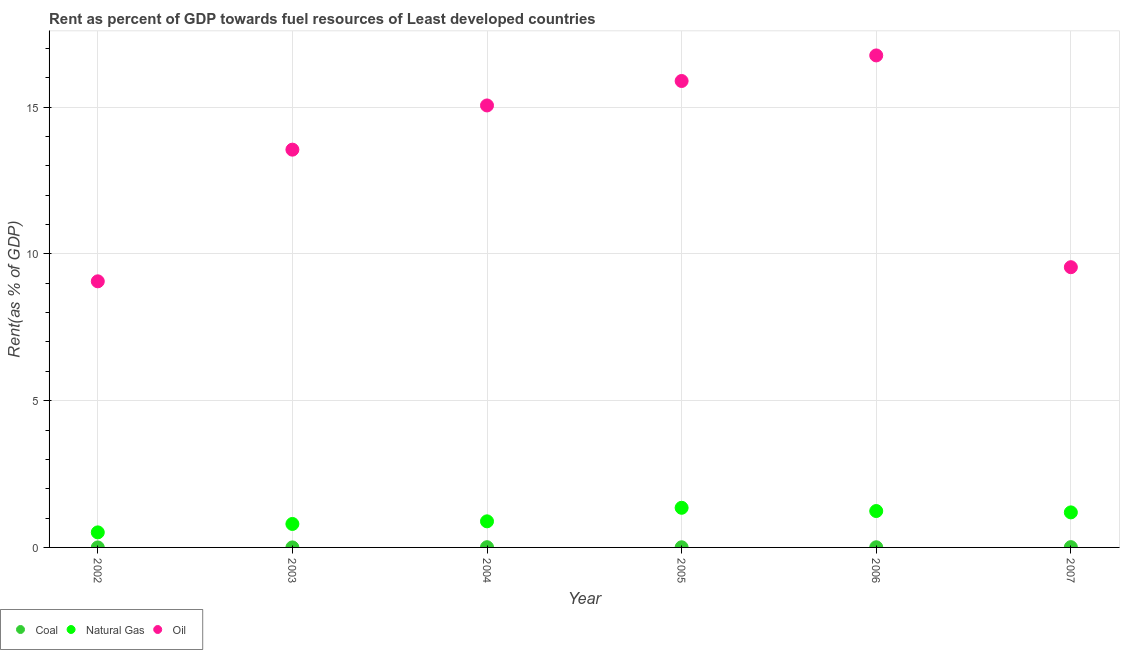How many different coloured dotlines are there?
Offer a very short reply. 3. What is the rent towards oil in 2007?
Make the answer very short. 9.55. Across all years, what is the maximum rent towards oil?
Your answer should be compact. 16.76. Across all years, what is the minimum rent towards natural gas?
Your answer should be very brief. 0.51. In which year was the rent towards coal minimum?
Your response must be concise. 2002. What is the total rent towards oil in the graph?
Your answer should be compact. 79.86. What is the difference between the rent towards natural gas in 2002 and that in 2005?
Provide a short and direct response. -0.84. What is the difference between the rent towards oil in 2003 and the rent towards natural gas in 2005?
Offer a terse response. 12.2. What is the average rent towards coal per year?
Your response must be concise. 0. In the year 2004, what is the difference between the rent towards oil and rent towards natural gas?
Ensure brevity in your answer.  14.17. In how many years, is the rent towards oil greater than 4 %?
Ensure brevity in your answer.  6. What is the ratio of the rent towards coal in 2002 to that in 2006?
Your answer should be very brief. 0.04. Is the rent towards natural gas in 2003 less than that in 2006?
Provide a succinct answer. Yes. Is the difference between the rent towards natural gas in 2004 and 2006 greater than the difference between the rent towards oil in 2004 and 2006?
Offer a very short reply. Yes. What is the difference between the highest and the second highest rent towards natural gas?
Your answer should be very brief. 0.11. What is the difference between the highest and the lowest rent towards oil?
Ensure brevity in your answer.  7.7. Is the sum of the rent towards coal in 2005 and 2006 greater than the maximum rent towards natural gas across all years?
Give a very brief answer. No. Is the rent towards oil strictly greater than the rent towards coal over the years?
Give a very brief answer. Yes. Is the rent towards oil strictly less than the rent towards natural gas over the years?
Provide a succinct answer. No. How many dotlines are there?
Offer a terse response. 3. How many years are there in the graph?
Your response must be concise. 6. What is the difference between two consecutive major ticks on the Y-axis?
Provide a succinct answer. 5. How are the legend labels stacked?
Offer a very short reply. Horizontal. What is the title of the graph?
Provide a succinct answer. Rent as percent of GDP towards fuel resources of Least developed countries. Does "Tertiary" appear as one of the legend labels in the graph?
Your answer should be compact. No. What is the label or title of the X-axis?
Your answer should be very brief. Year. What is the label or title of the Y-axis?
Your answer should be compact. Rent(as % of GDP). What is the Rent(as % of GDP) of Coal in 2002?
Give a very brief answer. 0. What is the Rent(as % of GDP) of Natural Gas in 2002?
Your answer should be very brief. 0.51. What is the Rent(as % of GDP) in Oil in 2002?
Your response must be concise. 9.06. What is the Rent(as % of GDP) of Coal in 2003?
Ensure brevity in your answer.  0. What is the Rent(as % of GDP) in Natural Gas in 2003?
Offer a terse response. 0.8. What is the Rent(as % of GDP) in Oil in 2003?
Keep it short and to the point. 13.55. What is the Rent(as % of GDP) in Coal in 2004?
Offer a terse response. 0.01. What is the Rent(as % of GDP) of Natural Gas in 2004?
Give a very brief answer. 0.89. What is the Rent(as % of GDP) in Oil in 2004?
Offer a very short reply. 15.06. What is the Rent(as % of GDP) in Coal in 2005?
Offer a terse response. 0. What is the Rent(as % of GDP) of Natural Gas in 2005?
Your answer should be compact. 1.35. What is the Rent(as % of GDP) of Oil in 2005?
Provide a short and direct response. 15.89. What is the Rent(as % of GDP) in Coal in 2006?
Offer a very short reply. 0.01. What is the Rent(as % of GDP) in Natural Gas in 2006?
Offer a very short reply. 1.24. What is the Rent(as % of GDP) in Oil in 2006?
Provide a short and direct response. 16.76. What is the Rent(as % of GDP) in Coal in 2007?
Ensure brevity in your answer.  0.01. What is the Rent(as % of GDP) in Natural Gas in 2007?
Ensure brevity in your answer.  1.19. What is the Rent(as % of GDP) of Oil in 2007?
Keep it short and to the point. 9.55. Across all years, what is the maximum Rent(as % of GDP) in Coal?
Ensure brevity in your answer.  0.01. Across all years, what is the maximum Rent(as % of GDP) in Natural Gas?
Give a very brief answer. 1.35. Across all years, what is the maximum Rent(as % of GDP) in Oil?
Your response must be concise. 16.76. Across all years, what is the minimum Rent(as % of GDP) in Coal?
Give a very brief answer. 0. Across all years, what is the minimum Rent(as % of GDP) of Natural Gas?
Your response must be concise. 0.51. Across all years, what is the minimum Rent(as % of GDP) in Oil?
Ensure brevity in your answer.  9.06. What is the total Rent(as % of GDP) in Coal in the graph?
Keep it short and to the point. 0.03. What is the total Rent(as % of GDP) in Natural Gas in the graph?
Ensure brevity in your answer.  5.98. What is the total Rent(as % of GDP) in Oil in the graph?
Give a very brief answer. 79.86. What is the difference between the Rent(as % of GDP) in Coal in 2002 and that in 2003?
Provide a short and direct response. -0. What is the difference between the Rent(as % of GDP) of Natural Gas in 2002 and that in 2003?
Give a very brief answer. -0.29. What is the difference between the Rent(as % of GDP) of Oil in 2002 and that in 2003?
Offer a terse response. -4.49. What is the difference between the Rent(as % of GDP) of Coal in 2002 and that in 2004?
Offer a terse response. -0.01. What is the difference between the Rent(as % of GDP) in Natural Gas in 2002 and that in 2004?
Ensure brevity in your answer.  -0.38. What is the difference between the Rent(as % of GDP) in Oil in 2002 and that in 2004?
Your response must be concise. -5.99. What is the difference between the Rent(as % of GDP) of Coal in 2002 and that in 2005?
Your answer should be very brief. -0. What is the difference between the Rent(as % of GDP) in Natural Gas in 2002 and that in 2005?
Offer a terse response. -0.84. What is the difference between the Rent(as % of GDP) in Oil in 2002 and that in 2005?
Make the answer very short. -6.82. What is the difference between the Rent(as % of GDP) in Coal in 2002 and that in 2006?
Give a very brief answer. -0.01. What is the difference between the Rent(as % of GDP) of Natural Gas in 2002 and that in 2006?
Offer a very short reply. -0.73. What is the difference between the Rent(as % of GDP) in Oil in 2002 and that in 2006?
Provide a succinct answer. -7.7. What is the difference between the Rent(as % of GDP) in Coal in 2002 and that in 2007?
Give a very brief answer. -0.01. What is the difference between the Rent(as % of GDP) in Natural Gas in 2002 and that in 2007?
Give a very brief answer. -0.68. What is the difference between the Rent(as % of GDP) in Oil in 2002 and that in 2007?
Offer a terse response. -0.48. What is the difference between the Rent(as % of GDP) of Coal in 2003 and that in 2004?
Provide a short and direct response. -0.01. What is the difference between the Rent(as % of GDP) of Natural Gas in 2003 and that in 2004?
Provide a short and direct response. -0.09. What is the difference between the Rent(as % of GDP) in Oil in 2003 and that in 2004?
Provide a succinct answer. -1.51. What is the difference between the Rent(as % of GDP) in Coal in 2003 and that in 2005?
Ensure brevity in your answer.  -0. What is the difference between the Rent(as % of GDP) in Natural Gas in 2003 and that in 2005?
Ensure brevity in your answer.  -0.55. What is the difference between the Rent(as % of GDP) of Oil in 2003 and that in 2005?
Ensure brevity in your answer.  -2.34. What is the difference between the Rent(as % of GDP) in Coal in 2003 and that in 2006?
Keep it short and to the point. -0.01. What is the difference between the Rent(as % of GDP) in Natural Gas in 2003 and that in 2006?
Your answer should be compact. -0.44. What is the difference between the Rent(as % of GDP) in Oil in 2003 and that in 2006?
Offer a very short reply. -3.21. What is the difference between the Rent(as % of GDP) in Coal in 2003 and that in 2007?
Make the answer very short. -0.01. What is the difference between the Rent(as % of GDP) in Natural Gas in 2003 and that in 2007?
Provide a succinct answer. -0.39. What is the difference between the Rent(as % of GDP) of Oil in 2003 and that in 2007?
Offer a very short reply. 4. What is the difference between the Rent(as % of GDP) of Coal in 2004 and that in 2005?
Keep it short and to the point. 0. What is the difference between the Rent(as % of GDP) in Natural Gas in 2004 and that in 2005?
Provide a short and direct response. -0.46. What is the difference between the Rent(as % of GDP) in Oil in 2004 and that in 2005?
Offer a terse response. -0.83. What is the difference between the Rent(as % of GDP) in Coal in 2004 and that in 2006?
Give a very brief answer. 0. What is the difference between the Rent(as % of GDP) of Natural Gas in 2004 and that in 2006?
Ensure brevity in your answer.  -0.35. What is the difference between the Rent(as % of GDP) of Oil in 2004 and that in 2006?
Provide a succinct answer. -1.7. What is the difference between the Rent(as % of GDP) of Coal in 2004 and that in 2007?
Provide a succinct answer. -0. What is the difference between the Rent(as % of GDP) in Natural Gas in 2004 and that in 2007?
Offer a very short reply. -0.3. What is the difference between the Rent(as % of GDP) of Oil in 2004 and that in 2007?
Give a very brief answer. 5.51. What is the difference between the Rent(as % of GDP) in Coal in 2005 and that in 2006?
Your response must be concise. -0. What is the difference between the Rent(as % of GDP) in Natural Gas in 2005 and that in 2006?
Give a very brief answer. 0.11. What is the difference between the Rent(as % of GDP) in Oil in 2005 and that in 2006?
Ensure brevity in your answer.  -0.87. What is the difference between the Rent(as % of GDP) of Coal in 2005 and that in 2007?
Make the answer very short. -0.01. What is the difference between the Rent(as % of GDP) in Natural Gas in 2005 and that in 2007?
Offer a terse response. 0.16. What is the difference between the Rent(as % of GDP) of Oil in 2005 and that in 2007?
Your answer should be compact. 6.34. What is the difference between the Rent(as % of GDP) of Coal in 2006 and that in 2007?
Offer a terse response. -0. What is the difference between the Rent(as % of GDP) of Natural Gas in 2006 and that in 2007?
Make the answer very short. 0.05. What is the difference between the Rent(as % of GDP) in Oil in 2006 and that in 2007?
Provide a short and direct response. 7.21. What is the difference between the Rent(as % of GDP) of Coal in 2002 and the Rent(as % of GDP) of Natural Gas in 2003?
Ensure brevity in your answer.  -0.8. What is the difference between the Rent(as % of GDP) of Coal in 2002 and the Rent(as % of GDP) of Oil in 2003?
Make the answer very short. -13.55. What is the difference between the Rent(as % of GDP) of Natural Gas in 2002 and the Rent(as % of GDP) of Oil in 2003?
Your response must be concise. -13.04. What is the difference between the Rent(as % of GDP) of Coal in 2002 and the Rent(as % of GDP) of Natural Gas in 2004?
Your answer should be very brief. -0.89. What is the difference between the Rent(as % of GDP) in Coal in 2002 and the Rent(as % of GDP) in Oil in 2004?
Offer a very short reply. -15.06. What is the difference between the Rent(as % of GDP) in Natural Gas in 2002 and the Rent(as % of GDP) in Oil in 2004?
Provide a succinct answer. -14.54. What is the difference between the Rent(as % of GDP) of Coal in 2002 and the Rent(as % of GDP) of Natural Gas in 2005?
Make the answer very short. -1.35. What is the difference between the Rent(as % of GDP) in Coal in 2002 and the Rent(as % of GDP) in Oil in 2005?
Keep it short and to the point. -15.89. What is the difference between the Rent(as % of GDP) of Natural Gas in 2002 and the Rent(as % of GDP) of Oil in 2005?
Ensure brevity in your answer.  -15.38. What is the difference between the Rent(as % of GDP) of Coal in 2002 and the Rent(as % of GDP) of Natural Gas in 2006?
Make the answer very short. -1.24. What is the difference between the Rent(as % of GDP) of Coal in 2002 and the Rent(as % of GDP) of Oil in 2006?
Provide a short and direct response. -16.76. What is the difference between the Rent(as % of GDP) of Natural Gas in 2002 and the Rent(as % of GDP) of Oil in 2006?
Provide a short and direct response. -16.25. What is the difference between the Rent(as % of GDP) in Coal in 2002 and the Rent(as % of GDP) in Natural Gas in 2007?
Provide a succinct answer. -1.19. What is the difference between the Rent(as % of GDP) in Coal in 2002 and the Rent(as % of GDP) in Oil in 2007?
Give a very brief answer. -9.55. What is the difference between the Rent(as % of GDP) of Natural Gas in 2002 and the Rent(as % of GDP) of Oil in 2007?
Ensure brevity in your answer.  -9.03. What is the difference between the Rent(as % of GDP) of Coal in 2003 and the Rent(as % of GDP) of Natural Gas in 2004?
Provide a short and direct response. -0.89. What is the difference between the Rent(as % of GDP) in Coal in 2003 and the Rent(as % of GDP) in Oil in 2004?
Make the answer very short. -15.06. What is the difference between the Rent(as % of GDP) of Natural Gas in 2003 and the Rent(as % of GDP) of Oil in 2004?
Offer a very short reply. -14.26. What is the difference between the Rent(as % of GDP) of Coal in 2003 and the Rent(as % of GDP) of Natural Gas in 2005?
Give a very brief answer. -1.35. What is the difference between the Rent(as % of GDP) in Coal in 2003 and the Rent(as % of GDP) in Oil in 2005?
Ensure brevity in your answer.  -15.89. What is the difference between the Rent(as % of GDP) in Natural Gas in 2003 and the Rent(as % of GDP) in Oil in 2005?
Offer a very short reply. -15.09. What is the difference between the Rent(as % of GDP) in Coal in 2003 and the Rent(as % of GDP) in Natural Gas in 2006?
Make the answer very short. -1.24. What is the difference between the Rent(as % of GDP) of Coal in 2003 and the Rent(as % of GDP) of Oil in 2006?
Provide a succinct answer. -16.76. What is the difference between the Rent(as % of GDP) in Natural Gas in 2003 and the Rent(as % of GDP) in Oil in 2006?
Offer a terse response. -15.96. What is the difference between the Rent(as % of GDP) of Coal in 2003 and the Rent(as % of GDP) of Natural Gas in 2007?
Offer a very short reply. -1.19. What is the difference between the Rent(as % of GDP) in Coal in 2003 and the Rent(as % of GDP) in Oil in 2007?
Offer a terse response. -9.55. What is the difference between the Rent(as % of GDP) in Natural Gas in 2003 and the Rent(as % of GDP) in Oil in 2007?
Make the answer very short. -8.75. What is the difference between the Rent(as % of GDP) in Coal in 2004 and the Rent(as % of GDP) in Natural Gas in 2005?
Provide a succinct answer. -1.34. What is the difference between the Rent(as % of GDP) of Coal in 2004 and the Rent(as % of GDP) of Oil in 2005?
Give a very brief answer. -15.88. What is the difference between the Rent(as % of GDP) of Natural Gas in 2004 and the Rent(as % of GDP) of Oil in 2005?
Offer a very short reply. -15. What is the difference between the Rent(as % of GDP) of Coal in 2004 and the Rent(as % of GDP) of Natural Gas in 2006?
Your answer should be very brief. -1.23. What is the difference between the Rent(as % of GDP) in Coal in 2004 and the Rent(as % of GDP) in Oil in 2006?
Offer a terse response. -16.75. What is the difference between the Rent(as % of GDP) of Natural Gas in 2004 and the Rent(as % of GDP) of Oil in 2006?
Give a very brief answer. -15.87. What is the difference between the Rent(as % of GDP) in Coal in 2004 and the Rent(as % of GDP) in Natural Gas in 2007?
Keep it short and to the point. -1.19. What is the difference between the Rent(as % of GDP) in Coal in 2004 and the Rent(as % of GDP) in Oil in 2007?
Offer a terse response. -9.54. What is the difference between the Rent(as % of GDP) in Natural Gas in 2004 and the Rent(as % of GDP) in Oil in 2007?
Keep it short and to the point. -8.66. What is the difference between the Rent(as % of GDP) of Coal in 2005 and the Rent(as % of GDP) of Natural Gas in 2006?
Make the answer very short. -1.23. What is the difference between the Rent(as % of GDP) in Coal in 2005 and the Rent(as % of GDP) in Oil in 2006?
Offer a very short reply. -16.75. What is the difference between the Rent(as % of GDP) in Natural Gas in 2005 and the Rent(as % of GDP) in Oil in 2006?
Give a very brief answer. -15.41. What is the difference between the Rent(as % of GDP) of Coal in 2005 and the Rent(as % of GDP) of Natural Gas in 2007?
Provide a short and direct response. -1.19. What is the difference between the Rent(as % of GDP) of Coal in 2005 and the Rent(as % of GDP) of Oil in 2007?
Keep it short and to the point. -9.54. What is the difference between the Rent(as % of GDP) in Natural Gas in 2005 and the Rent(as % of GDP) in Oil in 2007?
Offer a very short reply. -8.2. What is the difference between the Rent(as % of GDP) of Coal in 2006 and the Rent(as % of GDP) of Natural Gas in 2007?
Your answer should be very brief. -1.19. What is the difference between the Rent(as % of GDP) in Coal in 2006 and the Rent(as % of GDP) in Oil in 2007?
Make the answer very short. -9.54. What is the difference between the Rent(as % of GDP) of Natural Gas in 2006 and the Rent(as % of GDP) of Oil in 2007?
Give a very brief answer. -8.31. What is the average Rent(as % of GDP) of Coal per year?
Provide a short and direct response. 0. What is the average Rent(as % of GDP) of Oil per year?
Offer a terse response. 13.31. In the year 2002, what is the difference between the Rent(as % of GDP) in Coal and Rent(as % of GDP) in Natural Gas?
Offer a terse response. -0.51. In the year 2002, what is the difference between the Rent(as % of GDP) in Coal and Rent(as % of GDP) in Oil?
Provide a succinct answer. -9.06. In the year 2002, what is the difference between the Rent(as % of GDP) of Natural Gas and Rent(as % of GDP) of Oil?
Make the answer very short. -8.55. In the year 2003, what is the difference between the Rent(as % of GDP) in Coal and Rent(as % of GDP) in Natural Gas?
Ensure brevity in your answer.  -0.8. In the year 2003, what is the difference between the Rent(as % of GDP) in Coal and Rent(as % of GDP) in Oil?
Give a very brief answer. -13.55. In the year 2003, what is the difference between the Rent(as % of GDP) of Natural Gas and Rent(as % of GDP) of Oil?
Offer a very short reply. -12.75. In the year 2004, what is the difference between the Rent(as % of GDP) of Coal and Rent(as % of GDP) of Natural Gas?
Give a very brief answer. -0.88. In the year 2004, what is the difference between the Rent(as % of GDP) of Coal and Rent(as % of GDP) of Oil?
Provide a succinct answer. -15.05. In the year 2004, what is the difference between the Rent(as % of GDP) of Natural Gas and Rent(as % of GDP) of Oil?
Provide a succinct answer. -14.17. In the year 2005, what is the difference between the Rent(as % of GDP) in Coal and Rent(as % of GDP) in Natural Gas?
Provide a succinct answer. -1.35. In the year 2005, what is the difference between the Rent(as % of GDP) of Coal and Rent(as % of GDP) of Oil?
Your response must be concise. -15.88. In the year 2005, what is the difference between the Rent(as % of GDP) in Natural Gas and Rent(as % of GDP) in Oil?
Your response must be concise. -14.54. In the year 2006, what is the difference between the Rent(as % of GDP) in Coal and Rent(as % of GDP) in Natural Gas?
Keep it short and to the point. -1.23. In the year 2006, what is the difference between the Rent(as % of GDP) in Coal and Rent(as % of GDP) in Oil?
Offer a very short reply. -16.75. In the year 2006, what is the difference between the Rent(as % of GDP) of Natural Gas and Rent(as % of GDP) of Oil?
Keep it short and to the point. -15.52. In the year 2007, what is the difference between the Rent(as % of GDP) of Coal and Rent(as % of GDP) of Natural Gas?
Offer a terse response. -1.18. In the year 2007, what is the difference between the Rent(as % of GDP) of Coal and Rent(as % of GDP) of Oil?
Your response must be concise. -9.54. In the year 2007, what is the difference between the Rent(as % of GDP) of Natural Gas and Rent(as % of GDP) of Oil?
Give a very brief answer. -8.35. What is the ratio of the Rent(as % of GDP) of Coal in 2002 to that in 2003?
Offer a terse response. 0.79. What is the ratio of the Rent(as % of GDP) in Natural Gas in 2002 to that in 2003?
Provide a short and direct response. 0.64. What is the ratio of the Rent(as % of GDP) of Oil in 2002 to that in 2003?
Provide a succinct answer. 0.67. What is the ratio of the Rent(as % of GDP) of Coal in 2002 to that in 2004?
Make the answer very short. 0.03. What is the ratio of the Rent(as % of GDP) of Natural Gas in 2002 to that in 2004?
Offer a terse response. 0.58. What is the ratio of the Rent(as % of GDP) in Oil in 2002 to that in 2004?
Give a very brief answer. 0.6. What is the ratio of the Rent(as % of GDP) of Coal in 2002 to that in 2005?
Offer a very short reply. 0.05. What is the ratio of the Rent(as % of GDP) of Natural Gas in 2002 to that in 2005?
Your response must be concise. 0.38. What is the ratio of the Rent(as % of GDP) in Oil in 2002 to that in 2005?
Provide a short and direct response. 0.57. What is the ratio of the Rent(as % of GDP) of Coal in 2002 to that in 2006?
Your answer should be compact. 0.04. What is the ratio of the Rent(as % of GDP) in Natural Gas in 2002 to that in 2006?
Offer a very short reply. 0.41. What is the ratio of the Rent(as % of GDP) of Oil in 2002 to that in 2006?
Provide a short and direct response. 0.54. What is the ratio of the Rent(as % of GDP) of Coal in 2002 to that in 2007?
Provide a succinct answer. 0.02. What is the ratio of the Rent(as % of GDP) in Natural Gas in 2002 to that in 2007?
Keep it short and to the point. 0.43. What is the ratio of the Rent(as % of GDP) of Oil in 2002 to that in 2007?
Your answer should be very brief. 0.95. What is the ratio of the Rent(as % of GDP) in Coal in 2003 to that in 2004?
Provide a succinct answer. 0.04. What is the ratio of the Rent(as % of GDP) of Natural Gas in 2003 to that in 2004?
Provide a short and direct response. 0.9. What is the ratio of the Rent(as % of GDP) in Oil in 2003 to that in 2004?
Make the answer very short. 0.9. What is the ratio of the Rent(as % of GDP) of Coal in 2003 to that in 2005?
Provide a succinct answer. 0.06. What is the ratio of the Rent(as % of GDP) in Natural Gas in 2003 to that in 2005?
Ensure brevity in your answer.  0.59. What is the ratio of the Rent(as % of GDP) of Oil in 2003 to that in 2005?
Your response must be concise. 0.85. What is the ratio of the Rent(as % of GDP) in Coal in 2003 to that in 2006?
Ensure brevity in your answer.  0.05. What is the ratio of the Rent(as % of GDP) in Natural Gas in 2003 to that in 2006?
Offer a very short reply. 0.64. What is the ratio of the Rent(as % of GDP) of Oil in 2003 to that in 2006?
Provide a succinct answer. 0.81. What is the ratio of the Rent(as % of GDP) of Coal in 2003 to that in 2007?
Give a very brief answer. 0.03. What is the ratio of the Rent(as % of GDP) in Natural Gas in 2003 to that in 2007?
Your response must be concise. 0.67. What is the ratio of the Rent(as % of GDP) of Oil in 2003 to that in 2007?
Ensure brevity in your answer.  1.42. What is the ratio of the Rent(as % of GDP) of Coal in 2004 to that in 2005?
Keep it short and to the point. 1.6. What is the ratio of the Rent(as % of GDP) in Natural Gas in 2004 to that in 2005?
Provide a short and direct response. 0.66. What is the ratio of the Rent(as % of GDP) in Oil in 2004 to that in 2005?
Your answer should be compact. 0.95. What is the ratio of the Rent(as % of GDP) of Coal in 2004 to that in 2006?
Offer a terse response. 1.41. What is the ratio of the Rent(as % of GDP) in Natural Gas in 2004 to that in 2006?
Make the answer very short. 0.72. What is the ratio of the Rent(as % of GDP) of Oil in 2004 to that in 2006?
Offer a terse response. 0.9. What is the ratio of the Rent(as % of GDP) of Coal in 2004 to that in 2007?
Provide a succinct answer. 0.8. What is the ratio of the Rent(as % of GDP) in Natural Gas in 2004 to that in 2007?
Provide a short and direct response. 0.74. What is the ratio of the Rent(as % of GDP) of Oil in 2004 to that in 2007?
Ensure brevity in your answer.  1.58. What is the ratio of the Rent(as % of GDP) in Coal in 2005 to that in 2006?
Ensure brevity in your answer.  0.88. What is the ratio of the Rent(as % of GDP) of Natural Gas in 2005 to that in 2006?
Your answer should be very brief. 1.09. What is the ratio of the Rent(as % of GDP) in Oil in 2005 to that in 2006?
Offer a very short reply. 0.95. What is the ratio of the Rent(as % of GDP) of Coal in 2005 to that in 2007?
Keep it short and to the point. 0.5. What is the ratio of the Rent(as % of GDP) in Natural Gas in 2005 to that in 2007?
Your response must be concise. 1.13. What is the ratio of the Rent(as % of GDP) of Oil in 2005 to that in 2007?
Provide a short and direct response. 1.66. What is the ratio of the Rent(as % of GDP) of Coal in 2006 to that in 2007?
Offer a terse response. 0.57. What is the ratio of the Rent(as % of GDP) in Natural Gas in 2006 to that in 2007?
Offer a terse response. 1.04. What is the ratio of the Rent(as % of GDP) in Oil in 2006 to that in 2007?
Make the answer very short. 1.76. What is the difference between the highest and the second highest Rent(as % of GDP) of Coal?
Your answer should be very brief. 0. What is the difference between the highest and the second highest Rent(as % of GDP) of Natural Gas?
Your answer should be compact. 0.11. What is the difference between the highest and the second highest Rent(as % of GDP) of Oil?
Your answer should be compact. 0.87. What is the difference between the highest and the lowest Rent(as % of GDP) of Coal?
Your response must be concise. 0.01. What is the difference between the highest and the lowest Rent(as % of GDP) of Natural Gas?
Keep it short and to the point. 0.84. What is the difference between the highest and the lowest Rent(as % of GDP) in Oil?
Make the answer very short. 7.7. 